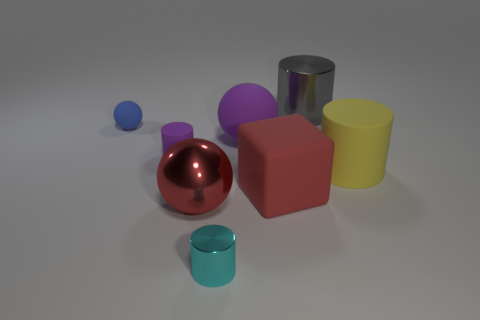Add 2 purple things. How many objects exist? 10 Subtract all large gray metal cylinders. How many cylinders are left? 3 Subtract all cubes. How many objects are left? 7 Add 5 purple metallic cubes. How many purple metallic cubes exist? 5 Subtract all gray cylinders. How many cylinders are left? 3 Subtract 1 yellow cylinders. How many objects are left? 7 Subtract all gray balls. Subtract all cyan cylinders. How many balls are left? 3 Subtract all green balls. How many purple cylinders are left? 1 Subtract all small blue things. Subtract all small blue balls. How many objects are left? 6 Add 4 red rubber things. How many red rubber things are left? 5 